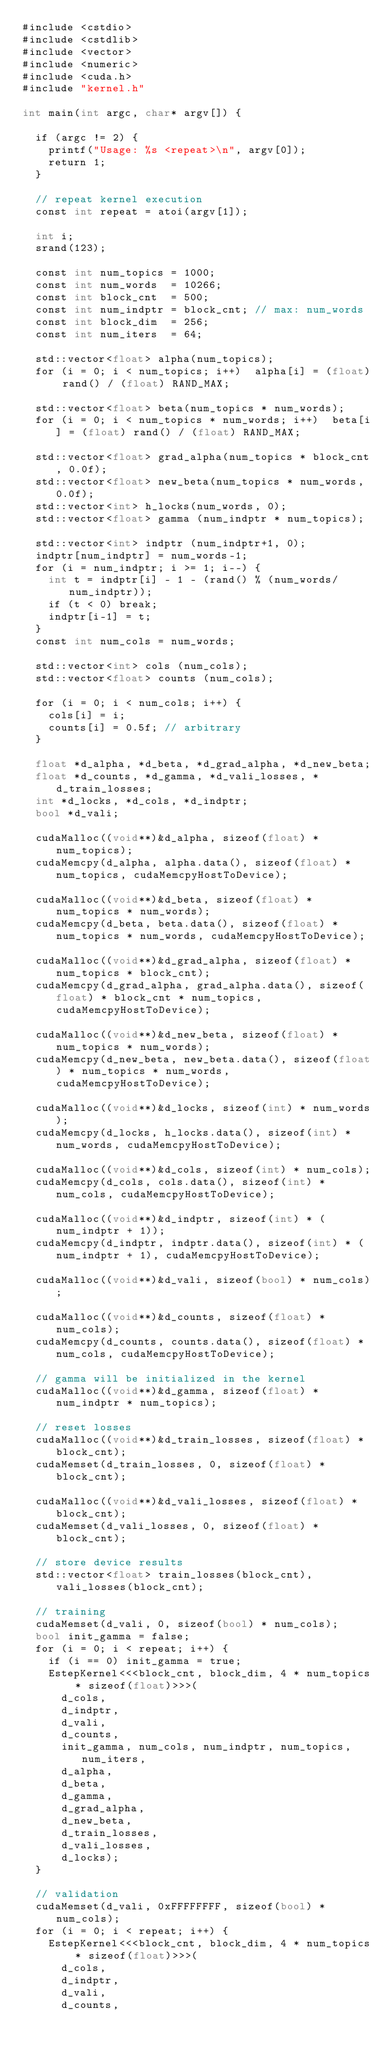Convert code to text. <code><loc_0><loc_0><loc_500><loc_500><_Cuda_>#include <cstdio>
#include <cstdlib>
#include <vector>
#include <numeric>
#include <cuda.h>
#include "kernel.h"

int main(int argc, char* argv[]) {

  if (argc != 2) {
    printf("Usage: %s <repeat>\n", argv[0]);
    return 1;
  }

  // repeat kernel execution
  const int repeat = atoi(argv[1]);

  int i;
  srand(123);

  const int num_topics = 1000;
  const int num_words  = 10266;
  const int block_cnt  = 500;
  const int num_indptr = block_cnt; // max: num_words
  const int block_dim  = 256;
  const int num_iters  = 64;
 
  std::vector<float> alpha(num_topics);
  for (i = 0; i < num_topics; i++)  alpha[i] = (float) rand() / (float) RAND_MAX;

  std::vector<float> beta(num_topics * num_words);
  for (i = 0; i < num_topics * num_words; i++)  beta[i] = (float) rand() / (float) RAND_MAX;

  std::vector<float> grad_alpha(num_topics * block_cnt, 0.0f);
  std::vector<float> new_beta(num_topics * num_words, 0.0f);
  std::vector<int> h_locks(num_words, 0);
  std::vector<float> gamma (num_indptr * num_topics);

  std::vector<int> indptr (num_indptr+1, 0);
  indptr[num_indptr] = num_words-1;
  for (i = num_indptr; i >= 1; i--) {
    int t = indptr[i] - 1 - (rand() % (num_words/num_indptr));
    if (t < 0) break;
    indptr[i-1] = t;
  }
  const int num_cols = num_words;

  std::vector<int> cols (num_cols);
  std::vector<float> counts (num_cols);

  for (i = 0; i < num_cols; i++) {
    cols[i] = i;
    counts[i] = 0.5f; // arbitrary
  }

  float *d_alpha, *d_beta, *d_grad_alpha, *d_new_beta;
  float *d_counts, *d_gamma, *d_vali_losses, *d_train_losses;
  int *d_locks, *d_cols, *d_indptr;
  bool *d_vali;

  cudaMalloc((void**)&d_alpha, sizeof(float) * num_topics);
  cudaMemcpy(d_alpha, alpha.data(), sizeof(float) * num_topics, cudaMemcpyHostToDevice);

  cudaMalloc((void**)&d_beta, sizeof(float) * num_topics * num_words);
  cudaMemcpy(d_beta, beta.data(), sizeof(float) * num_topics * num_words, cudaMemcpyHostToDevice);

  cudaMalloc((void**)&d_grad_alpha, sizeof(float) * num_topics * block_cnt);
  cudaMemcpy(d_grad_alpha, grad_alpha.data(), sizeof(float) * block_cnt * num_topics, cudaMemcpyHostToDevice);

  cudaMalloc((void**)&d_new_beta, sizeof(float) * num_topics * num_words);
  cudaMemcpy(d_new_beta, new_beta.data(), sizeof(float) * num_topics * num_words, cudaMemcpyHostToDevice);

  cudaMalloc((void**)&d_locks, sizeof(int) * num_words);
  cudaMemcpy(d_locks, h_locks.data(), sizeof(int) * num_words, cudaMemcpyHostToDevice);
  
  cudaMalloc((void**)&d_cols, sizeof(int) * num_cols);
  cudaMemcpy(d_cols, cols.data(), sizeof(int) * num_cols, cudaMemcpyHostToDevice);

  cudaMalloc((void**)&d_indptr, sizeof(int) * (num_indptr + 1));
  cudaMemcpy(d_indptr, indptr.data(), sizeof(int) * (num_indptr + 1), cudaMemcpyHostToDevice);

  cudaMalloc((void**)&d_vali, sizeof(bool) * num_cols);

  cudaMalloc((void**)&d_counts, sizeof(float) * num_cols);
  cudaMemcpy(d_counts, counts.data(), sizeof(float) * num_cols, cudaMemcpyHostToDevice);

  // gamma will be initialized in the kernel
  cudaMalloc((void**)&d_gamma, sizeof(float) * num_indptr * num_topics);

  // reset losses
  cudaMalloc((void**)&d_train_losses, sizeof(float) * block_cnt);
  cudaMemset(d_train_losses, 0, sizeof(float) * block_cnt);

  cudaMalloc((void**)&d_vali_losses, sizeof(float) * block_cnt);
  cudaMemset(d_vali_losses, 0, sizeof(float) * block_cnt);

  // store device results
  std::vector<float> train_losses(block_cnt), vali_losses(block_cnt);

  // training
  cudaMemset(d_vali, 0, sizeof(bool) * num_cols); 
  bool init_gamma = false;
  for (i = 0; i < repeat; i++) {
    if (i == 0) init_gamma = true;
    EstepKernel<<<block_cnt, block_dim, 4 * num_topics * sizeof(float)>>>(
      d_cols,
      d_indptr,
      d_vali,
      d_counts,
      init_gamma, num_cols, num_indptr, num_topics, num_iters,
      d_alpha,
      d_beta,
      d_gamma,
      d_grad_alpha,
      d_new_beta,
      d_train_losses,
      d_vali_losses,
      d_locks);
  }

  // validation
  cudaMemset(d_vali, 0xFFFFFFFF, sizeof(bool) * num_cols); 
  for (i = 0; i < repeat; i++) {
    EstepKernel<<<block_cnt, block_dim, 4 * num_topics * sizeof(float)>>>(
      d_cols,
      d_indptr,
      d_vali,
      d_counts,</code> 